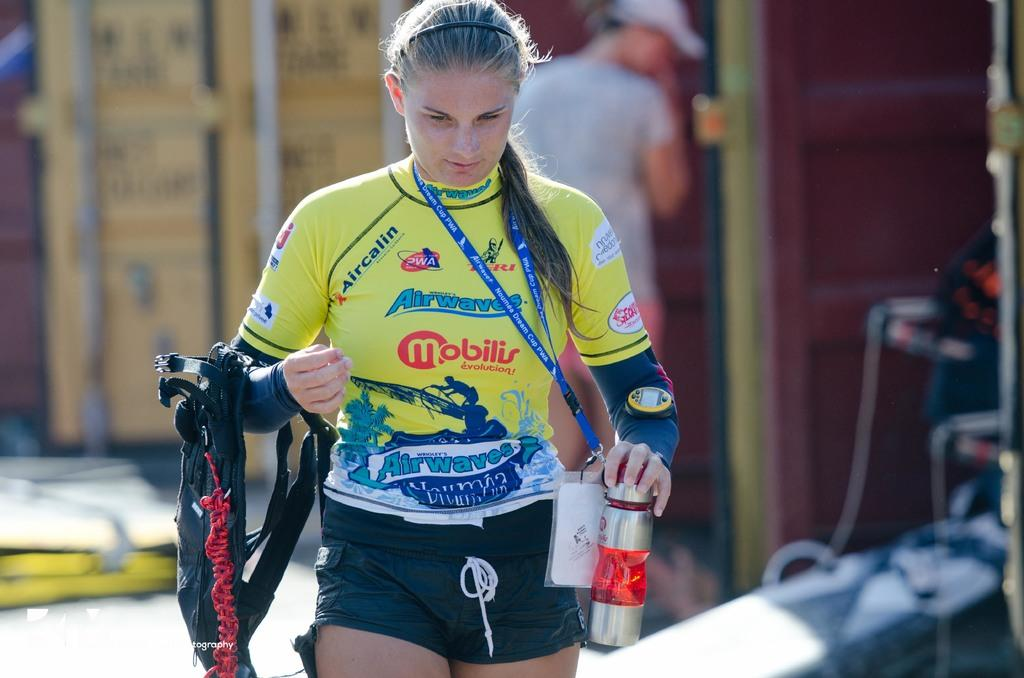<image>
Summarize the visual content of the image. A woman wearing a yellow jersey with printed sponsors on it including Mobilis Evolution is walking with a water bottle in one hand and the other carrying a harness. 